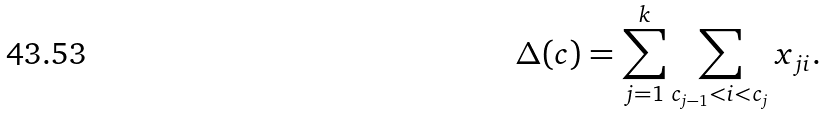<formula> <loc_0><loc_0><loc_500><loc_500>\Delta ( c ) = \sum _ { j = 1 } ^ { k } \sum _ { c _ { j - 1 } < i < c _ { j } } x _ { j i } .</formula> 